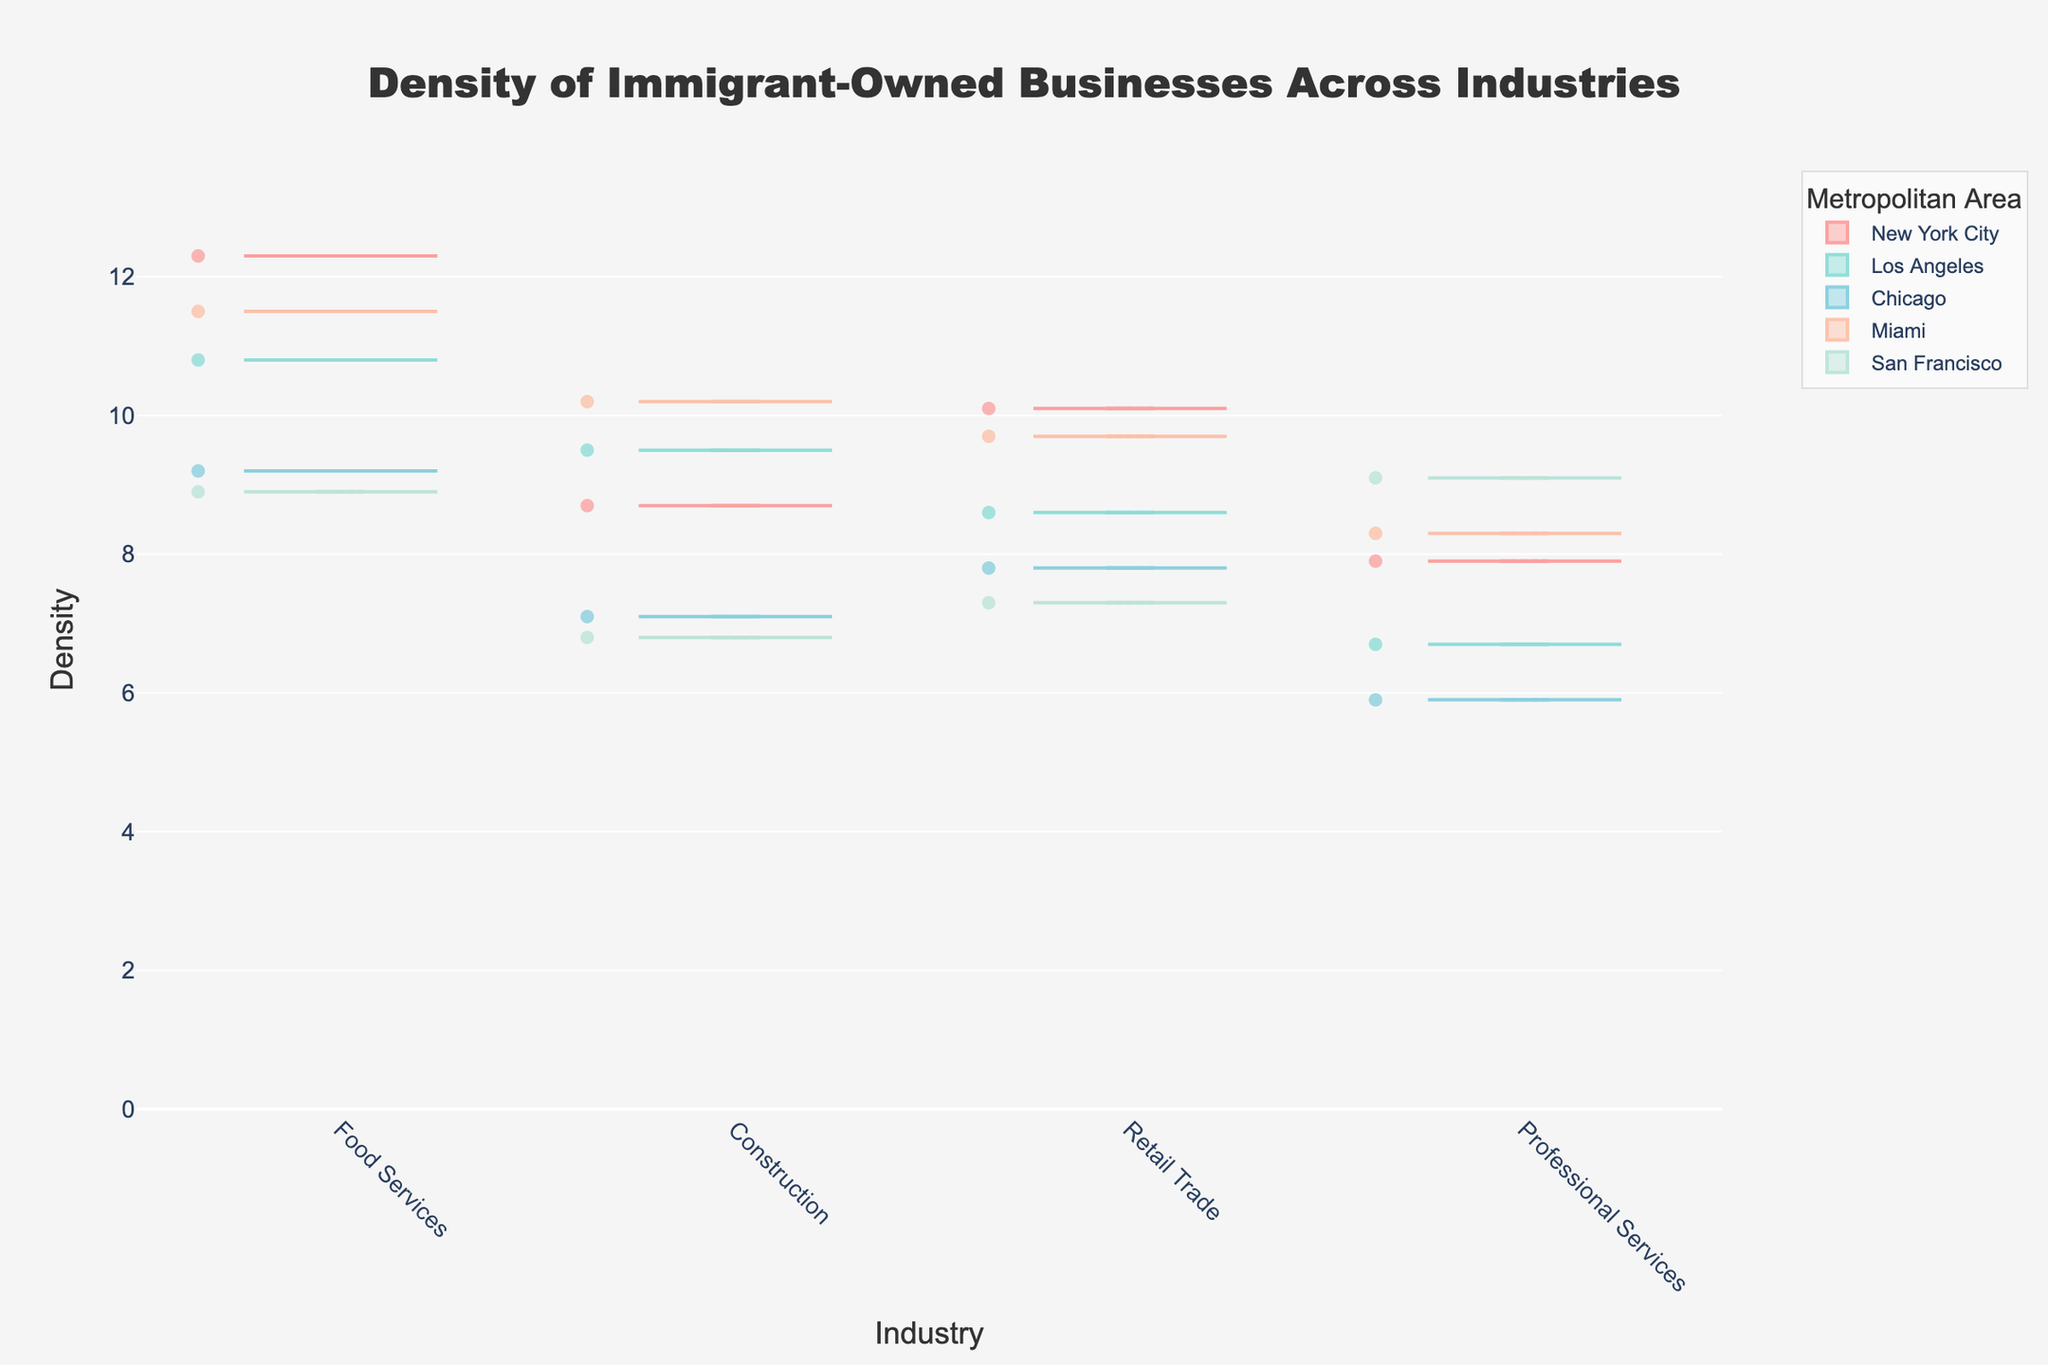what is the title of the figure? The title is displayed at the top and usually summarizes the content and purpose of the figure. By looking at the top of the figure, the title "Density of Immigrant-Owned Businesses Across Industries" can be found.
Answer: Density of Immigrant-Owned Businesses Across Industries Which industry has the highest density of immigrant-owned businesses in New York City? Look at the violin plots for New York City and identify the one with the highest point on the y-axis. The "Food Services" industry has the highest density at 12.3.
Answer: Food Services What is the average density of immigrant-owned businesses in the "Retail Trade" industry across all metropolitan areas? Find the densities of "Retail Trade" in all areas: New York City (10.1), Los Angeles (8.6), Chicago (7.8), Miami (9.7), San Francisco (7.3). Calculate the average: (10.1 + 8.6 + 7.8 + 9.7 + 7.3) / 5 = 8.7
Answer: 8.7 Which metropolitan area has the most uniformly distributed densities across industries? Evaluate the spread of densities across the industries. Miami shows less variation with densities closer together (Food Services:11.5, Construction:10.2, Retail Trade:9.7, Professional Services:8.3).
Answer: Miami Which metropolitan area has the lowest density for immigrant-owned businesses in "Professional Services"? Check each area for the density value in "Professional Services". Chicago has the lowest at 5.9.
Answer: Chicago Compare the density of immigrant-owned businesses in "Construction" between New York City and Miami. Which is higher and by how much? Find the density values: New York City (8.7), Miami (10.2). The difference is 10.2 - 8.7 = 1.5, with Miami being higher.
Answer: Miami by 1.5 What is the range of density values for immigrant-owned businesses in Los Angeles? Identify the highest and lowest densities in Los Angeles: highest is Food Services (10.8) and lowest is Professional Services (6.7). Range is 10.8 - 6.7 = 4.1
Answer: 4.1 Is the density of immigrant-owned businesses in "Food Services" higher in Los Angeles or Chicago, and what are the values? Compare the "Food Services" densities: Los Angeles (10.8) and Chicago (9.2). Los Angeles is higher.
Answer: Los Angeles (10.8), Chicago (9.2) Which metropolitan area has the most immigrant-owned businesses in the "Professional Services" industry? Find the highest "Professional Services" density: New York City (7.9), Los Angeles (6.7), Chicago (5.9), Miami (8.3), San Francisco (9.1). San Francisco is the highest.
Answer: San Francisco What is the density difference between "Food Services" and "Professional Services" in San Francisco? Identify San Francisco densities: "Food Services" (8.9), "Professional Services" (9.1). Difference is 9.1 - 8.9 = 0.2.
Answer: 0.2 